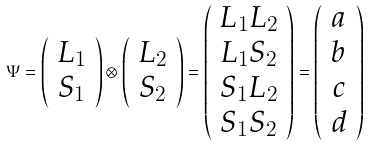Convert formula to latex. <formula><loc_0><loc_0><loc_500><loc_500>\Psi = \left ( \begin{array} { c } L _ { 1 } \\ S _ { 1 } \end{array} \right ) \otimes \left ( \begin{array} { c } L _ { 2 } \\ S _ { 2 } \end{array} \right ) = \left ( \begin{array} { c } L _ { 1 } L _ { 2 } \\ L _ { 1 } S _ { 2 } \\ S _ { 1 } L _ { 2 } \\ S _ { 1 } S _ { 2 } \end{array} \right ) = \left ( \begin{array} { c } a \\ b \\ c \\ d \end{array} \right )</formula> 